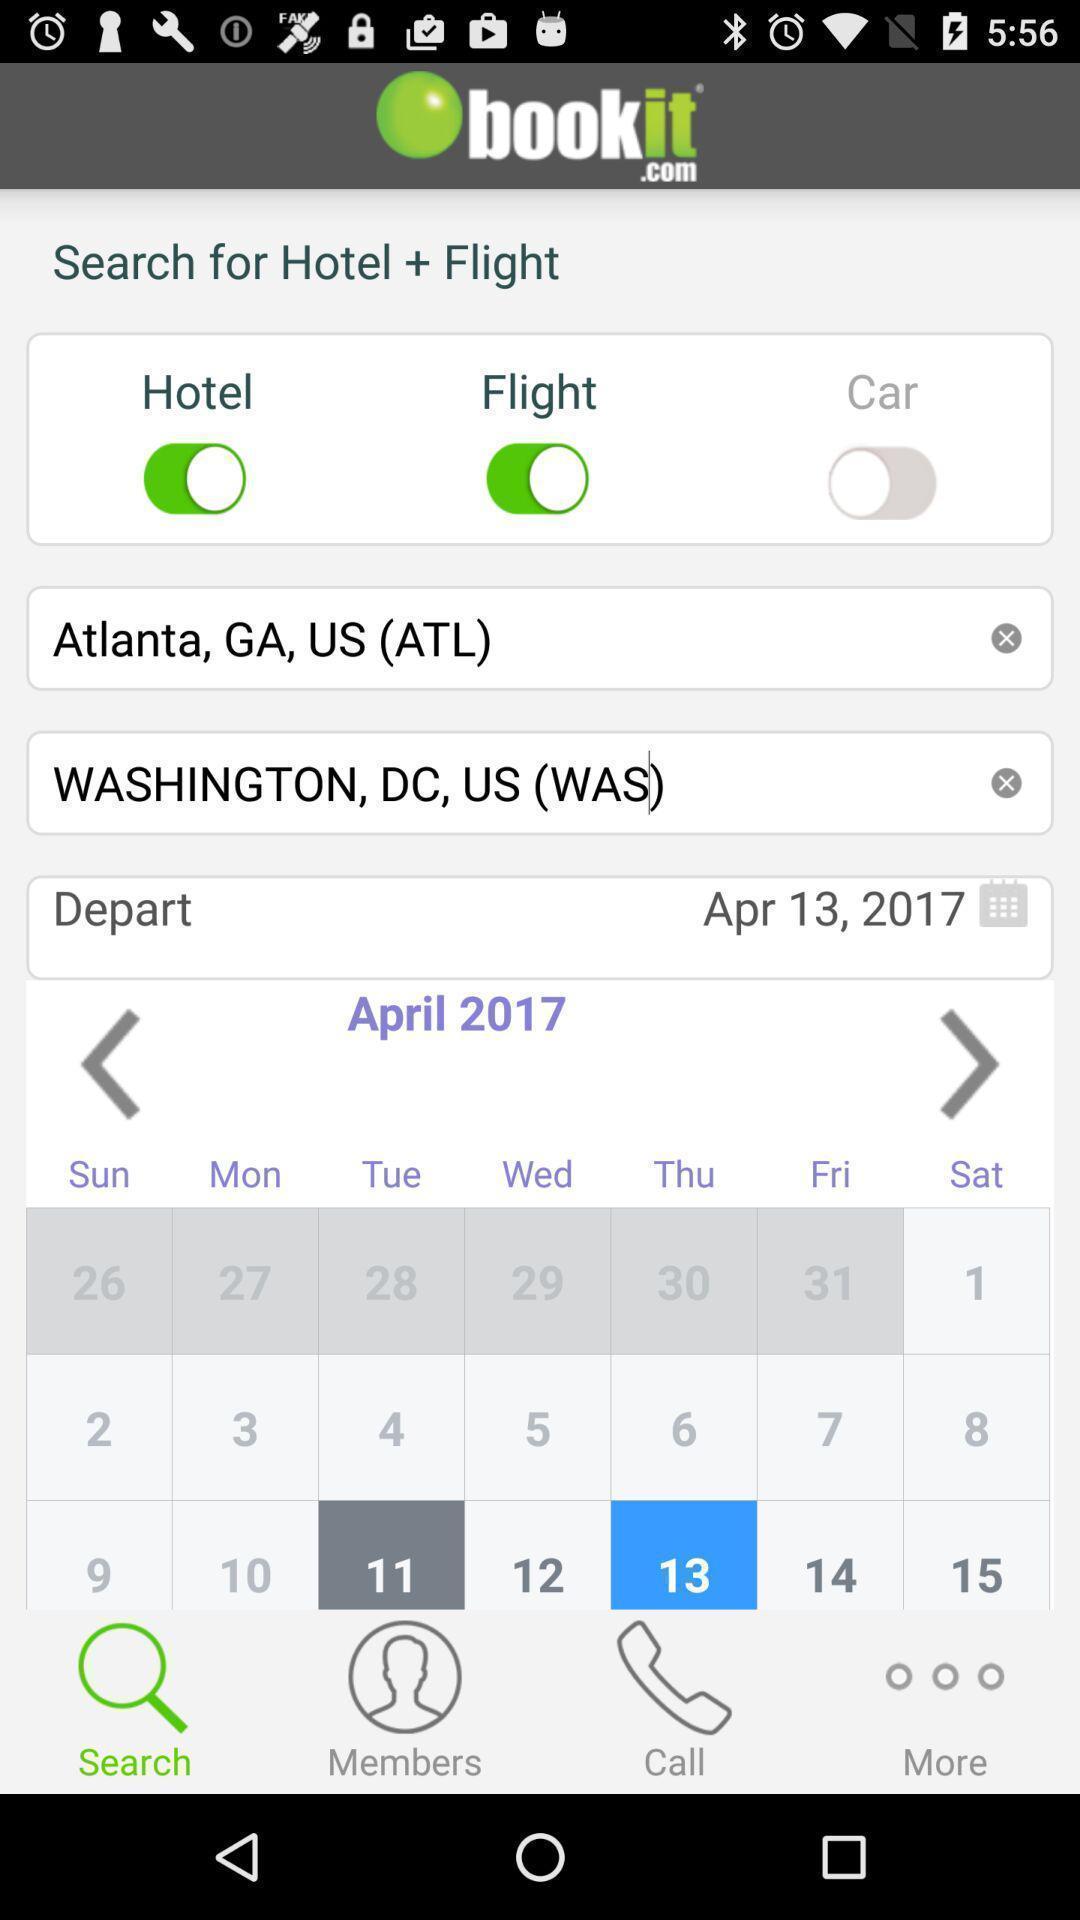Please provide a description for this image. Page for booking hotel and flight on particular date. 